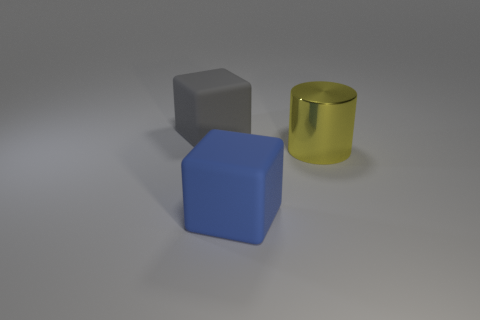Add 3 large gray spheres. How many objects exist? 6 Subtract all cylinders. How many objects are left? 2 Subtract 0 brown balls. How many objects are left? 3 Subtract all yellow shiny cylinders. Subtract all cylinders. How many objects are left? 1 Add 1 big objects. How many big objects are left? 4 Add 3 tiny green rubber things. How many tiny green rubber things exist? 3 